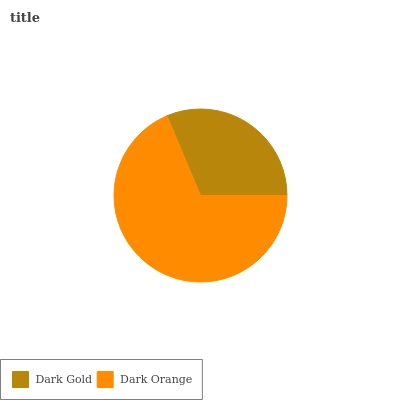Is Dark Gold the minimum?
Answer yes or no. Yes. Is Dark Orange the maximum?
Answer yes or no. Yes. Is Dark Orange the minimum?
Answer yes or no. No. Is Dark Orange greater than Dark Gold?
Answer yes or no. Yes. Is Dark Gold less than Dark Orange?
Answer yes or no. Yes. Is Dark Gold greater than Dark Orange?
Answer yes or no. No. Is Dark Orange less than Dark Gold?
Answer yes or no. No. Is Dark Orange the high median?
Answer yes or no. Yes. Is Dark Gold the low median?
Answer yes or no. Yes. Is Dark Gold the high median?
Answer yes or no. No. Is Dark Orange the low median?
Answer yes or no. No. 